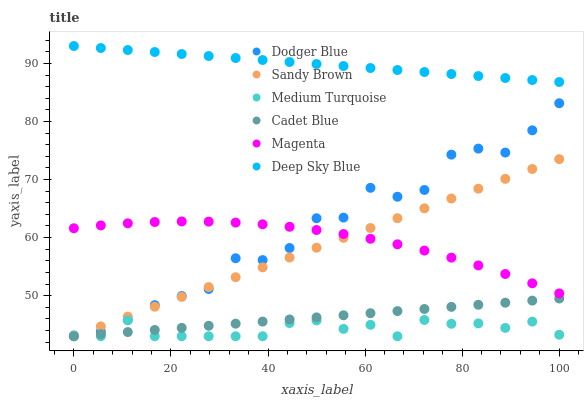Does Medium Turquoise have the minimum area under the curve?
Answer yes or no. Yes. Does Deep Sky Blue have the maximum area under the curve?
Answer yes or no. Yes. Does Dodger Blue have the minimum area under the curve?
Answer yes or no. No. Does Dodger Blue have the maximum area under the curve?
Answer yes or no. No. Is Cadet Blue the smoothest?
Answer yes or no. Yes. Is Dodger Blue the roughest?
Answer yes or no. Yes. Is Medium Turquoise the smoothest?
Answer yes or no. No. Is Medium Turquoise the roughest?
Answer yes or no. No. Does Cadet Blue have the lowest value?
Answer yes or no. Yes. Does Dodger Blue have the lowest value?
Answer yes or no. No. Does Deep Sky Blue have the highest value?
Answer yes or no. Yes. Does Dodger Blue have the highest value?
Answer yes or no. No. Is Cadet Blue less than Magenta?
Answer yes or no. Yes. Is Deep Sky Blue greater than Dodger Blue?
Answer yes or no. Yes. Does Magenta intersect Sandy Brown?
Answer yes or no. Yes. Is Magenta less than Sandy Brown?
Answer yes or no. No. Is Magenta greater than Sandy Brown?
Answer yes or no. No. Does Cadet Blue intersect Magenta?
Answer yes or no. No. 